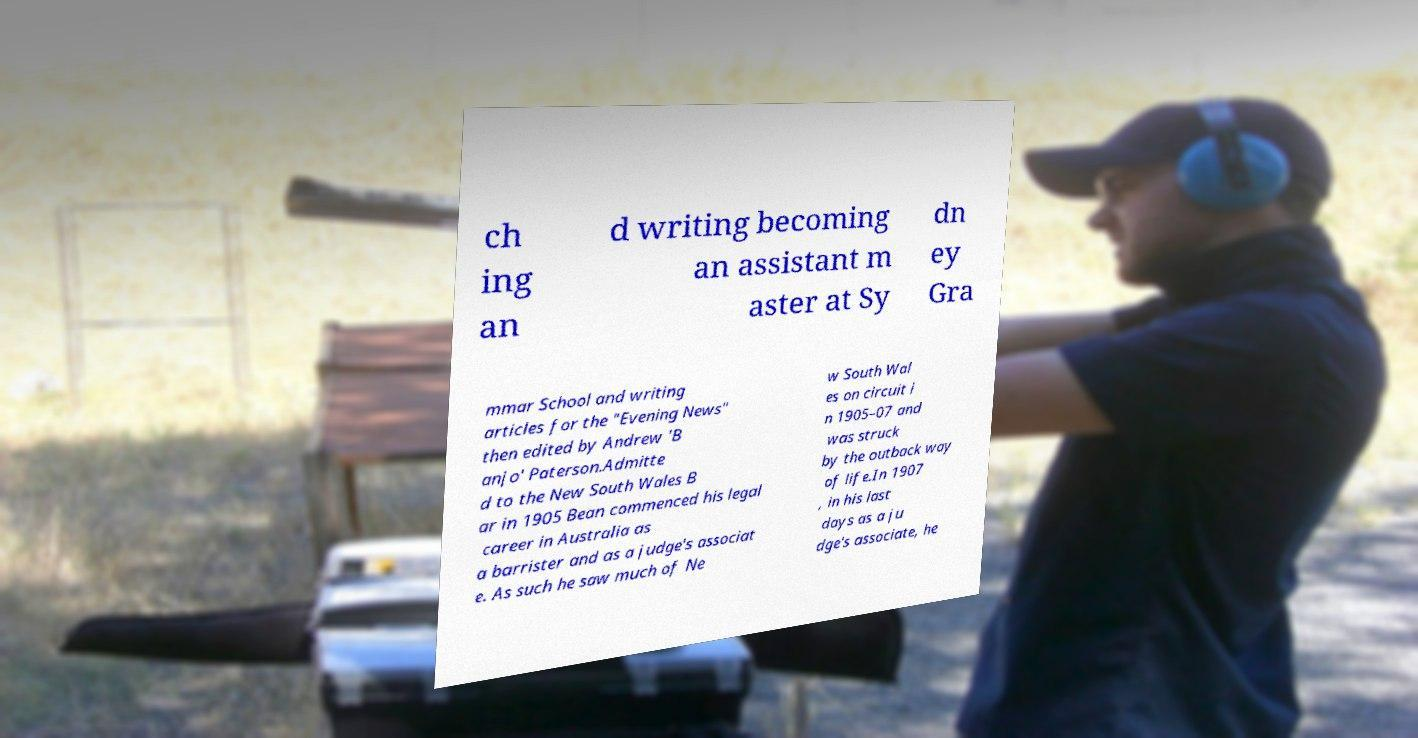Please identify and transcribe the text found in this image. ch ing an d writing becoming an assistant m aster at Sy dn ey Gra mmar School and writing articles for the "Evening News" then edited by Andrew 'B anjo' Paterson.Admitte d to the New South Wales B ar in 1905 Bean commenced his legal career in Australia as a barrister and as a judge's associat e. As such he saw much of Ne w South Wal es on circuit i n 1905–07 and was struck by the outback way of life.In 1907 , in his last days as a ju dge's associate, he 